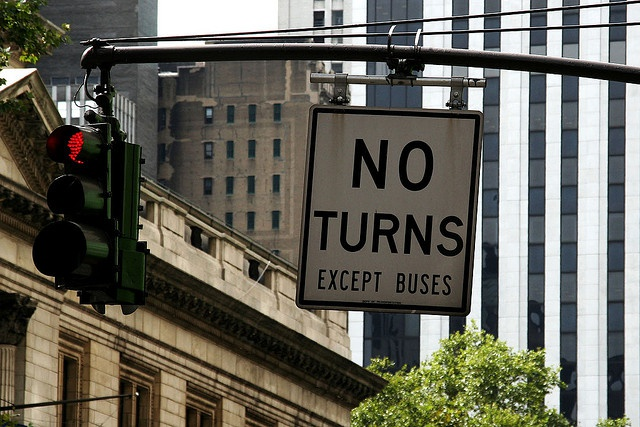Describe the objects in this image and their specific colors. I can see a traffic light in black, gray, darkgreen, and maroon tones in this image. 